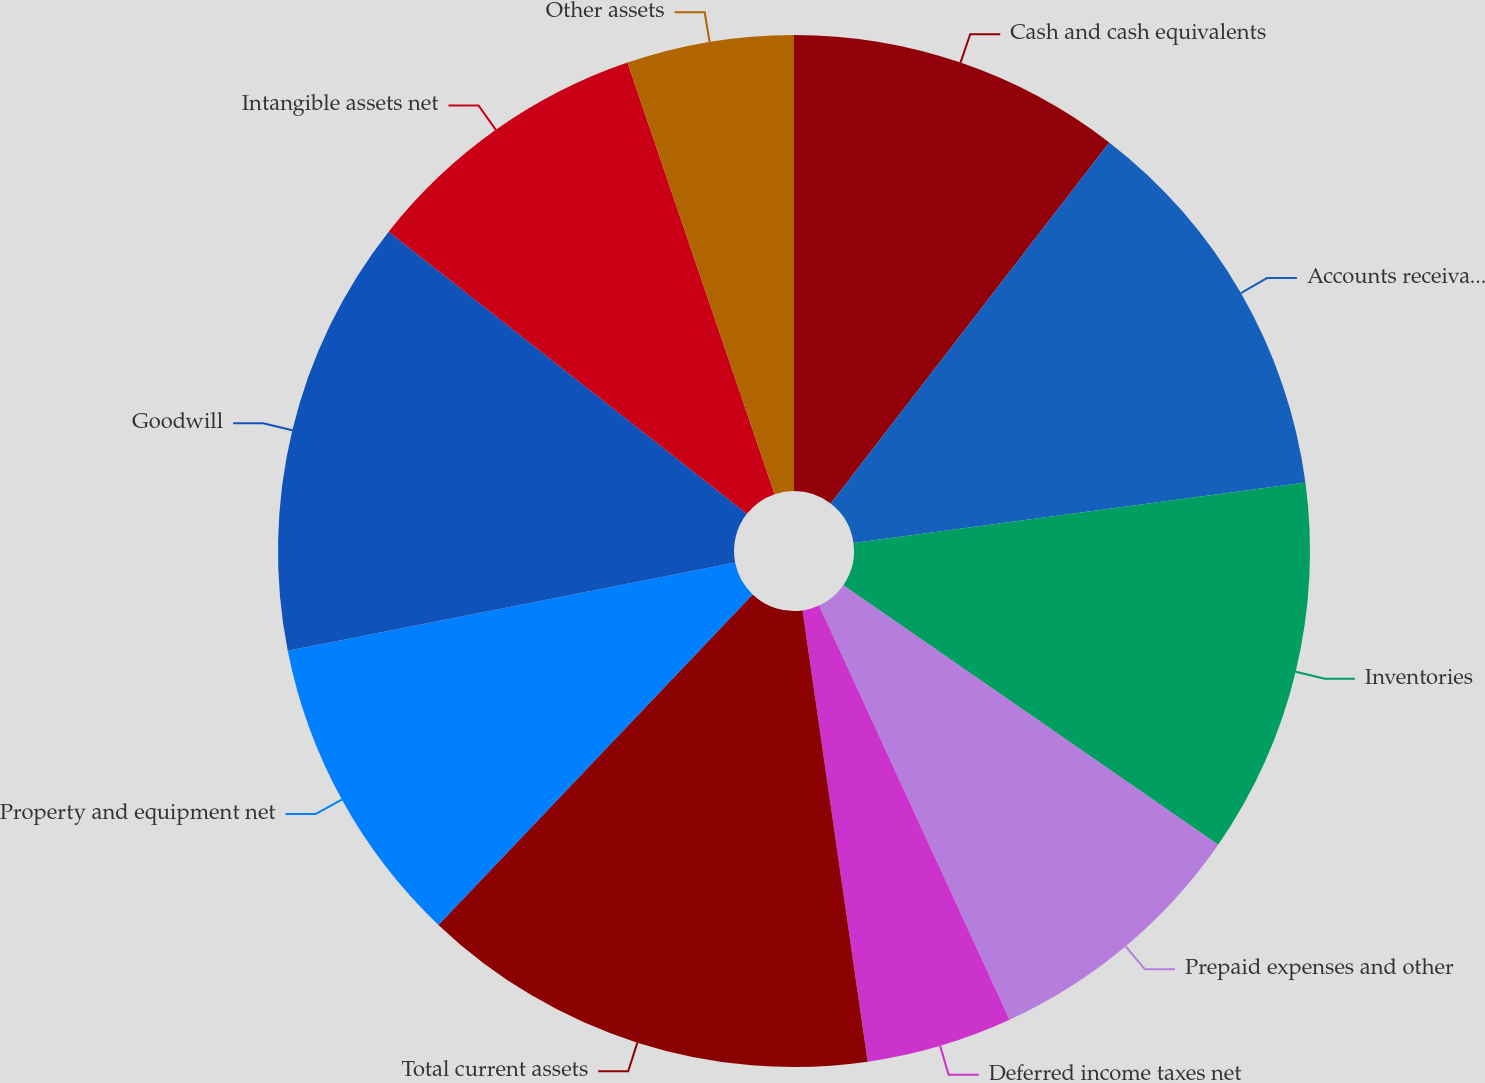<chart> <loc_0><loc_0><loc_500><loc_500><pie_chart><fcel>Cash and cash equivalents<fcel>Accounts receivable net<fcel>Inventories<fcel>Prepaid expenses and other<fcel>Deferred income taxes net<fcel>Total current assets<fcel>Property and equipment net<fcel>Goodwill<fcel>Intangible assets net<fcel>Other assets<nl><fcel>10.46%<fcel>12.42%<fcel>11.76%<fcel>8.5%<fcel>4.58%<fcel>14.38%<fcel>9.8%<fcel>13.72%<fcel>9.15%<fcel>5.23%<nl></chart> 